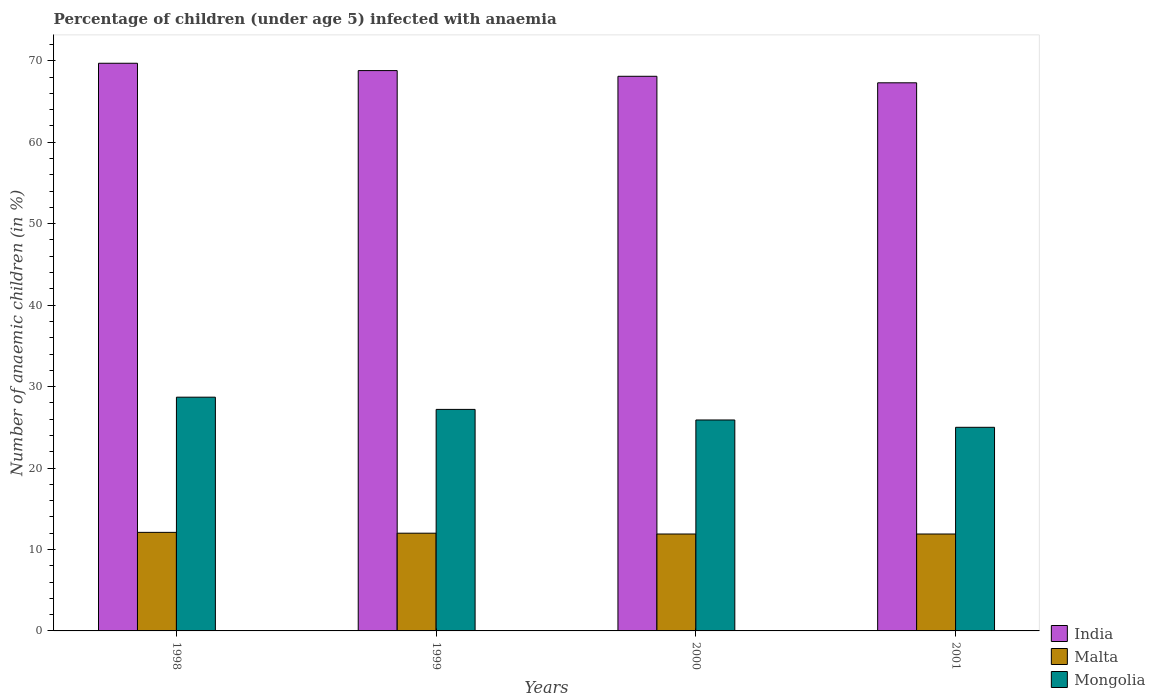How many groups of bars are there?
Make the answer very short. 4. Are the number of bars per tick equal to the number of legend labels?
Your response must be concise. Yes. Are the number of bars on each tick of the X-axis equal?
Give a very brief answer. Yes. What is the label of the 4th group of bars from the left?
Make the answer very short. 2001. In how many cases, is the number of bars for a given year not equal to the number of legend labels?
Make the answer very short. 0. What is the percentage of children infected with anaemia in in Mongolia in 1999?
Provide a short and direct response. 27.2. Across all years, what is the maximum percentage of children infected with anaemia in in India?
Provide a succinct answer. 69.7. Across all years, what is the minimum percentage of children infected with anaemia in in Malta?
Keep it short and to the point. 11.9. In which year was the percentage of children infected with anaemia in in Mongolia minimum?
Keep it short and to the point. 2001. What is the total percentage of children infected with anaemia in in India in the graph?
Provide a succinct answer. 273.9. What is the difference between the percentage of children infected with anaemia in in Mongolia in 1999 and that in 2000?
Offer a terse response. 1.3. What is the difference between the percentage of children infected with anaemia in in Mongolia in 2000 and the percentage of children infected with anaemia in in Malta in 1998?
Ensure brevity in your answer.  13.8. What is the average percentage of children infected with anaemia in in India per year?
Provide a succinct answer. 68.47. In the year 2000, what is the difference between the percentage of children infected with anaemia in in India and percentage of children infected with anaemia in in Malta?
Keep it short and to the point. 56.2. What is the ratio of the percentage of children infected with anaemia in in India in 1998 to that in 2000?
Keep it short and to the point. 1.02. What is the difference between the highest and the second highest percentage of children infected with anaemia in in Mongolia?
Provide a succinct answer. 1.5. What is the difference between the highest and the lowest percentage of children infected with anaemia in in India?
Your response must be concise. 2.4. What does the 2nd bar from the left in 1998 represents?
Your response must be concise. Malta. What does the 3rd bar from the right in 2000 represents?
Your answer should be very brief. India. Is it the case that in every year, the sum of the percentage of children infected with anaemia in in Malta and percentage of children infected with anaemia in in Mongolia is greater than the percentage of children infected with anaemia in in India?
Make the answer very short. No. How many years are there in the graph?
Provide a succinct answer. 4. What is the difference between two consecutive major ticks on the Y-axis?
Your answer should be compact. 10. Does the graph contain grids?
Your answer should be compact. No. Where does the legend appear in the graph?
Provide a short and direct response. Bottom right. How are the legend labels stacked?
Offer a terse response. Vertical. What is the title of the graph?
Ensure brevity in your answer.  Percentage of children (under age 5) infected with anaemia. What is the label or title of the X-axis?
Make the answer very short. Years. What is the label or title of the Y-axis?
Offer a very short reply. Number of anaemic children (in %). What is the Number of anaemic children (in %) of India in 1998?
Ensure brevity in your answer.  69.7. What is the Number of anaemic children (in %) of Malta in 1998?
Give a very brief answer. 12.1. What is the Number of anaemic children (in %) in Mongolia in 1998?
Provide a succinct answer. 28.7. What is the Number of anaemic children (in %) in India in 1999?
Your answer should be very brief. 68.8. What is the Number of anaemic children (in %) of Malta in 1999?
Provide a short and direct response. 12. What is the Number of anaemic children (in %) of Mongolia in 1999?
Offer a terse response. 27.2. What is the Number of anaemic children (in %) in India in 2000?
Your response must be concise. 68.1. What is the Number of anaemic children (in %) in Mongolia in 2000?
Offer a very short reply. 25.9. What is the Number of anaemic children (in %) in India in 2001?
Provide a short and direct response. 67.3. What is the Number of anaemic children (in %) in Malta in 2001?
Provide a short and direct response. 11.9. Across all years, what is the maximum Number of anaemic children (in %) of India?
Keep it short and to the point. 69.7. Across all years, what is the maximum Number of anaemic children (in %) in Malta?
Your response must be concise. 12.1. Across all years, what is the maximum Number of anaemic children (in %) in Mongolia?
Provide a short and direct response. 28.7. Across all years, what is the minimum Number of anaemic children (in %) in India?
Keep it short and to the point. 67.3. What is the total Number of anaemic children (in %) of India in the graph?
Give a very brief answer. 273.9. What is the total Number of anaemic children (in %) in Malta in the graph?
Make the answer very short. 47.9. What is the total Number of anaemic children (in %) of Mongolia in the graph?
Provide a short and direct response. 106.8. What is the difference between the Number of anaemic children (in %) of Malta in 1998 and that in 1999?
Provide a succinct answer. 0.1. What is the difference between the Number of anaemic children (in %) of Mongolia in 1998 and that in 1999?
Make the answer very short. 1.5. What is the difference between the Number of anaemic children (in %) of Malta in 1998 and that in 2000?
Give a very brief answer. 0.2. What is the difference between the Number of anaemic children (in %) in Mongolia in 1998 and that in 2000?
Make the answer very short. 2.8. What is the difference between the Number of anaemic children (in %) in Mongolia in 1998 and that in 2001?
Offer a very short reply. 3.7. What is the difference between the Number of anaemic children (in %) of Malta in 1999 and that in 2000?
Offer a terse response. 0.1. What is the difference between the Number of anaemic children (in %) in Mongolia in 1999 and that in 2000?
Make the answer very short. 1.3. What is the difference between the Number of anaemic children (in %) in India in 1999 and that in 2001?
Provide a succinct answer. 1.5. What is the difference between the Number of anaemic children (in %) of India in 2000 and that in 2001?
Your answer should be very brief. 0.8. What is the difference between the Number of anaemic children (in %) of India in 1998 and the Number of anaemic children (in %) of Malta in 1999?
Your answer should be very brief. 57.7. What is the difference between the Number of anaemic children (in %) of India in 1998 and the Number of anaemic children (in %) of Mongolia in 1999?
Your answer should be compact. 42.5. What is the difference between the Number of anaemic children (in %) of Malta in 1998 and the Number of anaemic children (in %) of Mongolia in 1999?
Your answer should be compact. -15.1. What is the difference between the Number of anaemic children (in %) in India in 1998 and the Number of anaemic children (in %) in Malta in 2000?
Offer a terse response. 57.8. What is the difference between the Number of anaemic children (in %) in India in 1998 and the Number of anaemic children (in %) in Mongolia in 2000?
Offer a terse response. 43.8. What is the difference between the Number of anaemic children (in %) in India in 1998 and the Number of anaemic children (in %) in Malta in 2001?
Provide a succinct answer. 57.8. What is the difference between the Number of anaemic children (in %) in India in 1998 and the Number of anaemic children (in %) in Mongolia in 2001?
Keep it short and to the point. 44.7. What is the difference between the Number of anaemic children (in %) in India in 1999 and the Number of anaemic children (in %) in Malta in 2000?
Keep it short and to the point. 56.9. What is the difference between the Number of anaemic children (in %) in India in 1999 and the Number of anaemic children (in %) in Mongolia in 2000?
Keep it short and to the point. 42.9. What is the difference between the Number of anaemic children (in %) of India in 1999 and the Number of anaemic children (in %) of Malta in 2001?
Provide a short and direct response. 56.9. What is the difference between the Number of anaemic children (in %) in India in 1999 and the Number of anaemic children (in %) in Mongolia in 2001?
Offer a very short reply. 43.8. What is the difference between the Number of anaemic children (in %) of India in 2000 and the Number of anaemic children (in %) of Malta in 2001?
Give a very brief answer. 56.2. What is the difference between the Number of anaemic children (in %) in India in 2000 and the Number of anaemic children (in %) in Mongolia in 2001?
Make the answer very short. 43.1. What is the difference between the Number of anaemic children (in %) of Malta in 2000 and the Number of anaemic children (in %) of Mongolia in 2001?
Your answer should be compact. -13.1. What is the average Number of anaemic children (in %) of India per year?
Your answer should be very brief. 68.47. What is the average Number of anaemic children (in %) of Malta per year?
Your answer should be very brief. 11.97. What is the average Number of anaemic children (in %) in Mongolia per year?
Make the answer very short. 26.7. In the year 1998, what is the difference between the Number of anaemic children (in %) in India and Number of anaemic children (in %) in Malta?
Your response must be concise. 57.6. In the year 1998, what is the difference between the Number of anaemic children (in %) of Malta and Number of anaemic children (in %) of Mongolia?
Provide a short and direct response. -16.6. In the year 1999, what is the difference between the Number of anaemic children (in %) of India and Number of anaemic children (in %) of Malta?
Keep it short and to the point. 56.8. In the year 1999, what is the difference between the Number of anaemic children (in %) in India and Number of anaemic children (in %) in Mongolia?
Make the answer very short. 41.6. In the year 1999, what is the difference between the Number of anaemic children (in %) in Malta and Number of anaemic children (in %) in Mongolia?
Give a very brief answer. -15.2. In the year 2000, what is the difference between the Number of anaemic children (in %) in India and Number of anaemic children (in %) in Malta?
Make the answer very short. 56.2. In the year 2000, what is the difference between the Number of anaemic children (in %) of India and Number of anaemic children (in %) of Mongolia?
Ensure brevity in your answer.  42.2. In the year 2001, what is the difference between the Number of anaemic children (in %) in India and Number of anaemic children (in %) in Malta?
Keep it short and to the point. 55.4. In the year 2001, what is the difference between the Number of anaemic children (in %) of India and Number of anaemic children (in %) of Mongolia?
Your answer should be very brief. 42.3. In the year 2001, what is the difference between the Number of anaemic children (in %) in Malta and Number of anaemic children (in %) in Mongolia?
Offer a terse response. -13.1. What is the ratio of the Number of anaemic children (in %) in India in 1998 to that in 1999?
Ensure brevity in your answer.  1.01. What is the ratio of the Number of anaemic children (in %) in Malta in 1998 to that in 1999?
Keep it short and to the point. 1.01. What is the ratio of the Number of anaemic children (in %) in Mongolia in 1998 to that in 1999?
Make the answer very short. 1.06. What is the ratio of the Number of anaemic children (in %) of India in 1998 to that in 2000?
Your response must be concise. 1.02. What is the ratio of the Number of anaemic children (in %) of Malta in 1998 to that in 2000?
Your answer should be compact. 1.02. What is the ratio of the Number of anaemic children (in %) in Mongolia in 1998 to that in 2000?
Make the answer very short. 1.11. What is the ratio of the Number of anaemic children (in %) in India in 1998 to that in 2001?
Give a very brief answer. 1.04. What is the ratio of the Number of anaemic children (in %) in Malta in 1998 to that in 2001?
Offer a very short reply. 1.02. What is the ratio of the Number of anaemic children (in %) of Mongolia in 1998 to that in 2001?
Your answer should be very brief. 1.15. What is the ratio of the Number of anaemic children (in %) in India in 1999 to that in 2000?
Provide a short and direct response. 1.01. What is the ratio of the Number of anaemic children (in %) in Malta in 1999 to that in 2000?
Your answer should be very brief. 1.01. What is the ratio of the Number of anaemic children (in %) in Mongolia in 1999 to that in 2000?
Your response must be concise. 1.05. What is the ratio of the Number of anaemic children (in %) of India in 1999 to that in 2001?
Your answer should be compact. 1.02. What is the ratio of the Number of anaemic children (in %) in Malta in 1999 to that in 2001?
Your answer should be very brief. 1.01. What is the ratio of the Number of anaemic children (in %) in Mongolia in 1999 to that in 2001?
Provide a short and direct response. 1.09. What is the ratio of the Number of anaemic children (in %) of India in 2000 to that in 2001?
Your response must be concise. 1.01. What is the ratio of the Number of anaemic children (in %) of Malta in 2000 to that in 2001?
Your response must be concise. 1. What is the ratio of the Number of anaemic children (in %) in Mongolia in 2000 to that in 2001?
Keep it short and to the point. 1.04. What is the difference between the highest and the second highest Number of anaemic children (in %) in Mongolia?
Ensure brevity in your answer.  1.5. What is the difference between the highest and the lowest Number of anaemic children (in %) of India?
Your answer should be compact. 2.4. What is the difference between the highest and the lowest Number of anaemic children (in %) in Malta?
Ensure brevity in your answer.  0.2. What is the difference between the highest and the lowest Number of anaemic children (in %) of Mongolia?
Offer a terse response. 3.7. 